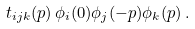<formula> <loc_0><loc_0><loc_500><loc_500>t _ { i j k } ( p ) \, \phi _ { i } ( 0 ) \phi _ { j } ( - p ) \phi _ { k } ( p ) \, .</formula> 